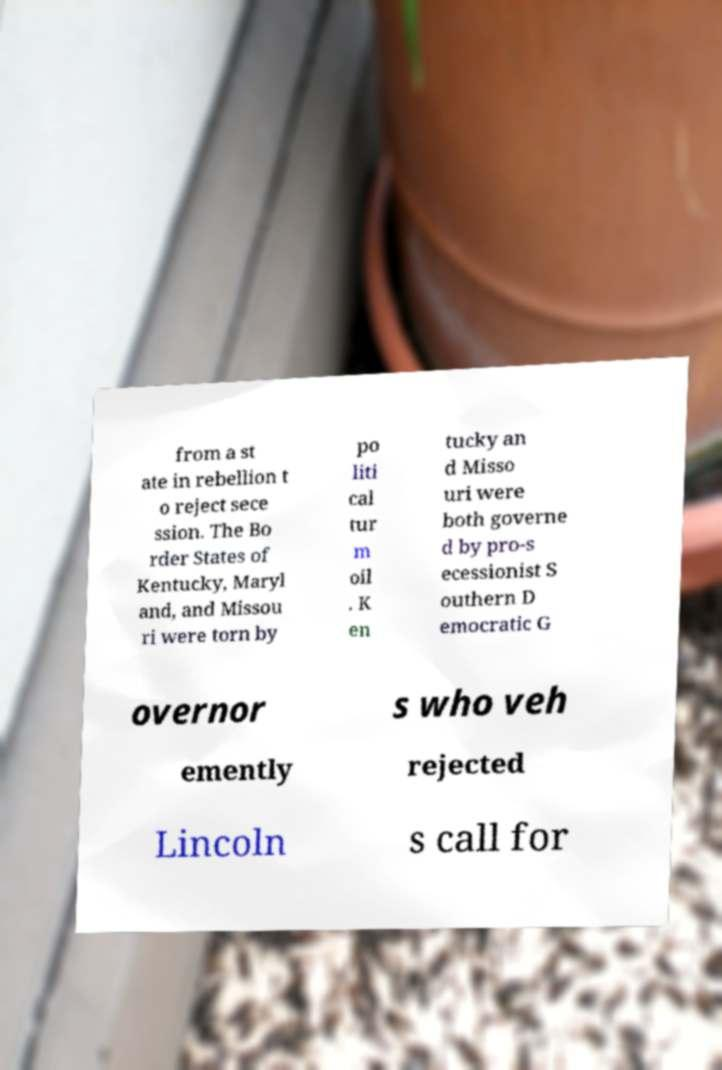Could you extract and type out the text from this image? from a st ate in rebellion t o reject sece ssion. The Bo rder States of Kentucky, Maryl and, and Missou ri were torn by po liti cal tur m oil . K en tucky an d Misso uri were both governe d by pro-s ecessionist S outhern D emocratic G overnor s who veh emently rejected Lincoln s call for 